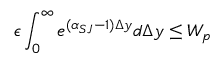<formula> <loc_0><loc_0><loc_500><loc_500>\epsilon \int _ { 0 } ^ { \infty } e ^ { ( \alpha _ { S J } - 1 ) \Delta y } d \Delta y \leq W _ { p }</formula> 